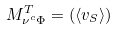Convert formula to latex. <formula><loc_0><loc_0><loc_500><loc_500>M ^ { T } _ { \nu ^ { c } \Phi } = ( \langle v _ { S } \rangle )</formula> 